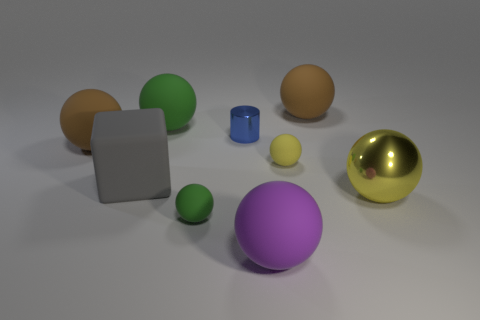How many spheres are cyan matte things or gray matte objects?
Make the answer very short. 0. What number of other objects are the same material as the big gray block?
Offer a very short reply. 6. What is the shape of the tiny rubber thing behind the gray cube?
Keep it short and to the point. Sphere. What material is the yellow ball in front of the yellow object behind the big gray matte thing?
Your response must be concise. Metal. Are there more large yellow things that are in front of the blue shiny cylinder than large purple metallic things?
Give a very brief answer. Yes. How many other things are the same color as the large shiny thing?
Offer a terse response. 1. The purple matte thing that is the same size as the yellow metal thing is what shape?
Your answer should be very brief. Sphere. How many big brown spheres are in front of the green sphere that is behind the green thing that is in front of the large yellow sphere?
Your response must be concise. 1. What number of rubber objects are either small purple balls or tiny things?
Keep it short and to the point. 2. There is a large sphere that is both on the right side of the blue cylinder and behind the large yellow thing; what is its color?
Offer a very short reply. Brown. 